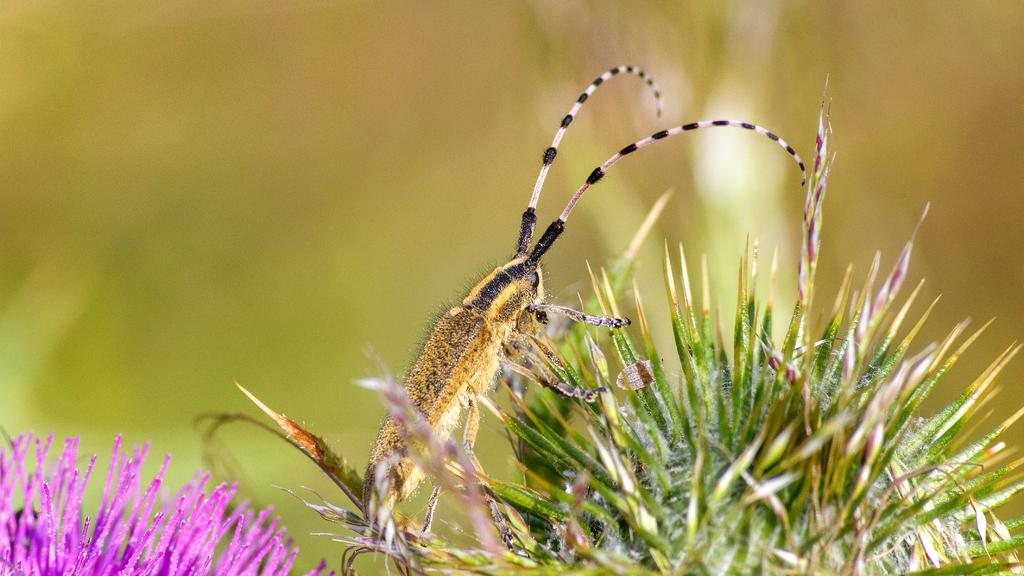What is the main subject of the image? There is a flower in the image. Is there anything else on the flower? Yes, there is an insect on the flower. Can you describe the background of the image? The background of the image is blurry. What type of wire is holding the coal in the image? There is no wire or coal present in the image; it features a flower with an insect on it. What season is depicted in the image? The provided facts do not mention any season, and the image does not show any specific seasonal elements. 